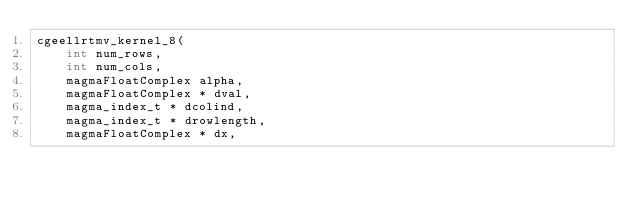Convert code to text. <code><loc_0><loc_0><loc_500><loc_500><_Cuda_>cgeellrtmv_kernel_8( 
    int num_rows, 
    int num_cols,
    magmaFloatComplex alpha, 
    magmaFloatComplex * dval, 
    magma_index_t * dcolind,
    magma_index_t * drowlength,
    magmaFloatComplex * dx,</code> 